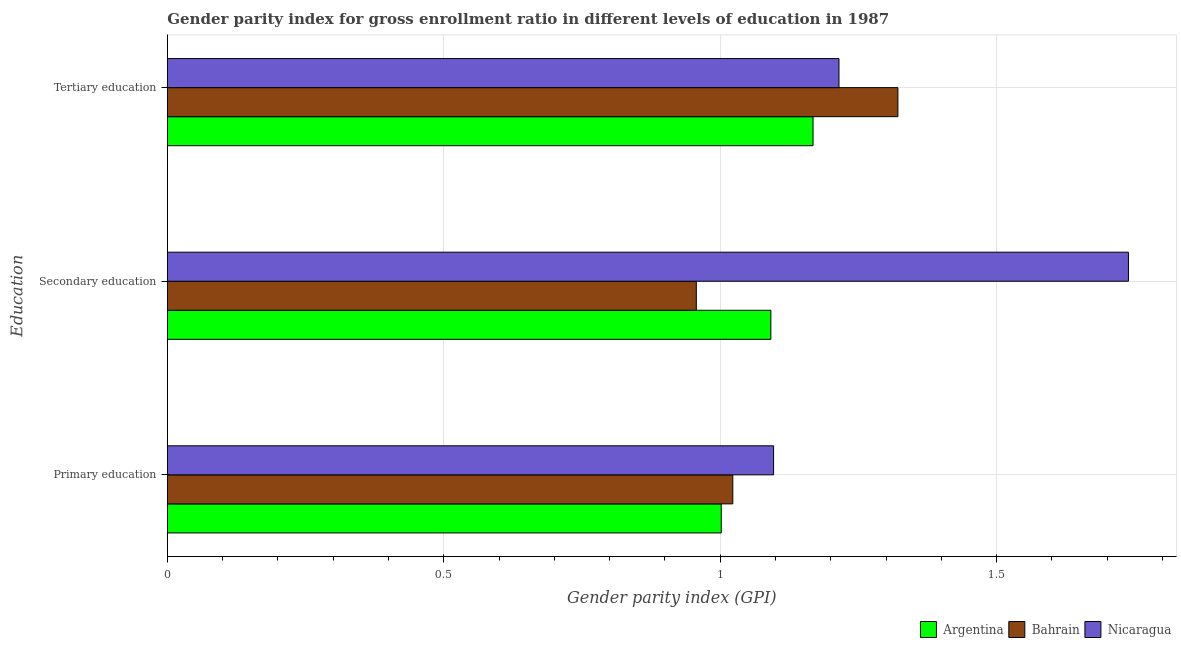How many different coloured bars are there?
Offer a terse response. 3. How many groups of bars are there?
Offer a terse response. 3. Are the number of bars per tick equal to the number of legend labels?
Provide a short and direct response. Yes. Are the number of bars on each tick of the Y-axis equal?
Your answer should be very brief. Yes. How many bars are there on the 1st tick from the top?
Make the answer very short. 3. How many bars are there on the 3rd tick from the bottom?
Provide a short and direct response. 3. What is the label of the 2nd group of bars from the top?
Your response must be concise. Secondary education. What is the gender parity index in primary education in Bahrain?
Offer a very short reply. 1.02. Across all countries, what is the maximum gender parity index in tertiary education?
Your answer should be compact. 1.32. Across all countries, what is the minimum gender parity index in secondary education?
Ensure brevity in your answer.  0.96. In which country was the gender parity index in secondary education maximum?
Your response must be concise. Nicaragua. What is the total gender parity index in secondary education in the graph?
Give a very brief answer. 3.79. What is the difference between the gender parity index in secondary education in Bahrain and that in Nicaragua?
Your answer should be compact. -0.78. What is the difference between the gender parity index in tertiary education in Bahrain and the gender parity index in secondary education in Nicaragua?
Give a very brief answer. -0.42. What is the average gender parity index in primary education per country?
Provide a short and direct response. 1.04. What is the difference between the gender parity index in primary education and gender parity index in secondary education in Argentina?
Your response must be concise. -0.09. In how many countries, is the gender parity index in primary education greater than 0.1 ?
Your answer should be very brief. 3. What is the ratio of the gender parity index in primary education in Bahrain to that in Argentina?
Offer a terse response. 1.02. Is the gender parity index in secondary education in Argentina less than that in Nicaragua?
Ensure brevity in your answer.  Yes. What is the difference between the highest and the second highest gender parity index in tertiary education?
Provide a short and direct response. 0.11. What is the difference between the highest and the lowest gender parity index in primary education?
Offer a terse response. 0.09. In how many countries, is the gender parity index in secondary education greater than the average gender parity index in secondary education taken over all countries?
Your response must be concise. 1. Is the sum of the gender parity index in tertiary education in Nicaragua and Argentina greater than the maximum gender parity index in primary education across all countries?
Keep it short and to the point. Yes. What does the 1st bar from the top in Tertiary education represents?
Your answer should be compact. Nicaragua. What does the 1st bar from the bottom in Secondary education represents?
Offer a very short reply. Argentina. Is it the case that in every country, the sum of the gender parity index in primary education and gender parity index in secondary education is greater than the gender parity index in tertiary education?
Offer a terse response. Yes. How many bars are there?
Your answer should be compact. 9. Are all the bars in the graph horizontal?
Your answer should be very brief. Yes. How many countries are there in the graph?
Provide a short and direct response. 3. Does the graph contain any zero values?
Provide a short and direct response. No. Does the graph contain grids?
Give a very brief answer. Yes. Where does the legend appear in the graph?
Offer a very short reply. Bottom right. How are the legend labels stacked?
Provide a short and direct response. Horizontal. What is the title of the graph?
Make the answer very short. Gender parity index for gross enrollment ratio in different levels of education in 1987. Does "Honduras" appear as one of the legend labels in the graph?
Offer a very short reply. No. What is the label or title of the X-axis?
Make the answer very short. Gender parity index (GPI). What is the label or title of the Y-axis?
Your answer should be compact. Education. What is the Gender parity index (GPI) of Argentina in Primary education?
Your response must be concise. 1. What is the Gender parity index (GPI) of Bahrain in Primary education?
Keep it short and to the point. 1.02. What is the Gender parity index (GPI) of Nicaragua in Primary education?
Offer a terse response. 1.1. What is the Gender parity index (GPI) of Argentina in Secondary education?
Give a very brief answer. 1.09. What is the Gender parity index (GPI) of Bahrain in Secondary education?
Keep it short and to the point. 0.96. What is the Gender parity index (GPI) in Nicaragua in Secondary education?
Ensure brevity in your answer.  1.74. What is the Gender parity index (GPI) in Argentina in Tertiary education?
Offer a terse response. 1.17. What is the Gender parity index (GPI) in Bahrain in Tertiary education?
Your answer should be compact. 1.32. What is the Gender parity index (GPI) of Nicaragua in Tertiary education?
Offer a very short reply. 1.21. Across all Education, what is the maximum Gender parity index (GPI) of Argentina?
Offer a terse response. 1.17. Across all Education, what is the maximum Gender parity index (GPI) of Bahrain?
Your answer should be very brief. 1.32. Across all Education, what is the maximum Gender parity index (GPI) of Nicaragua?
Make the answer very short. 1.74. Across all Education, what is the minimum Gender parity index (GPI) in Argentina?
Give a very brief answer. 1. Across all Education, what is the minimum Gender parity index (GPI) of Bahrain?
Your answer should be very brief. 0.96. Across all Education, what is the minimum Gender parity index (GPI) of Nicaragua?
Keep it short and to the point. 1.1. What is the total Gender parity index (GPI) in Argentina in the graph?
Offer a terse response. 3.26. What is the total Gender parity index (GPI) in Bahrain in the graph?
Make the answer very short. 3.3. What is the total Gender parity index (GPI) of Nicaragua in the graph?
Offer a very short reply. 4.05. What is the difference between the Gender parity index (GPI) of Argentina in Primary education and that in Secondary education?
Ensure brevity in your answer.  -0.09. What is the difference between the Gender parity index (GPI) in Bahrain in Primary education and that in Secondary education?
Your response must be concise. 0.07. What is the difference between the Gender parity index (GPI) of Nicaragua in Primary education and that in Secondary education?
Keep it short and to the point. -0.64. What is the difference between the Gender parity index (GPI) in Argentina in Primary education and that in Tertiary education?
Offer a terse response. -0.17. What is the difference between the Gender parity index (GPI) of Bahrain in Primary education and that in Tertiary education?
Your answer should be compact. -0.3. What is the difference between the Gender parity index (GPI) of Nicaragua in Primary education and that in Tertiary education?
Your answer should be very brief. -0.12. What is the difference between the Gender parity index (GPI) of Argentina in Secondary education and that in Tertiary education?
Your response must be concise. -0.08. What is the difference between the Gender parity index (GPI) in Bahrain in Secondary education and that in Tertiary education?
Keep it short and to the point. -0.36. What is the difference between the Gender parity index (GPI) in Nicaragua in Secondary education and that in Tertiary education?
Give a very brief answer. 0.52. What is the difference between the Gender parity index (GPI) in Argentina in Primary education and the Gender parity index (GPI) in Bahrain in Secondary education?
Provide a succinct answer. 0.05. What is the difference between the Gender parity index (GPI) in Argentina in Primary education and the Gender parity index (GPI) in Nicaragua in Secondary education?
Give a very brief answer. -0.74. What is the difference between the Gender parity index (GPI) of Bahrain in Primary education and the Gender parity index (GPI) of Nicaragua in Secondary education?
Your answer should be compact. -0.72. What is the difference between the Gender parity index (GPI) of Argentina in Primary education and the Gender parity index (GPI) of Bahrain in Tertiary education?
Make the answer very short. -0.32. What is the difference between the Gender parity index (GPI) of Argentina in Primary education and the Gender parity index (GPI) of Nicaragua in Tertiary education?
Your answer should be compact. -0.21. What is the difference between the Gender parity index (GPI) in Bahrain in Primary education and the Gender parity index (GPI) in Nicaragua in Tertiary education?
Ensure brevity in your answer.  -0.19. What is the difference between the Gender parity index (GPI) of Argentina in Secondary education and the Gender parity index (GPI) of Bahrain in Tertiary education?
Keep it short and to the point. -0.23. What is the difference between the Gender parity index (GPI) in Argentina in Secondary education and the Gender parity index (GPI) in Nicaragua in Tertiary education?
Your response must be concise. -0.12. What is the difference between the Gender parity index (GPI) of Bahrain in Secondary education and the Gender parity index (GPI) of Nicaragua in Tertiary education?
Offer a very short reply. -0.26. What is the average Gender parity index (GPI) of Argentina per Education?
Give a very brief answer. 1.09. What is the average Gender parity index (GPI) in Bahrain per Education?
Offer a terse response. 1.1. What is the average Gender parity index (GPI) in Nicaragua per Education?
Give a very brief answer. 1.35. What is the difference between the Gender parity index (GPI) of Argentina and Gender parity index (GPI) of Bahrain in Primary education?
Offer a very short reply. -0.02. What is the difference between the Gender parity index (GPI) of Argentina and Gender parity index (GPI) of Nicaragua in Primary education?
Keep it short and to the point. -0.09. What is the difference between the Gender parity index (GPI) of Bahrain and Gender parity index (GPI) of Nicaragua in Primary education?
Provide a short and direct response. -0.07. What is the difference between the Gender parity index (GPI) in Argentina and Gender parity index (GPI) in Bahrain in Secondary education?
Your answer should be very brief. 0.13. What is the difference between the Gender parity index (GPI) in Argentina and Gender parity index (GPI) in Nicaragua in Secondary education?
Provide a short and direct response. -0.65. What is the difference between the Gender parity index (GPI) of Bahrain and Gender parity index (GPI) of Nicaragua in Secondary education?
Your answer should be compact. -0.78. What is the difference between the Gender parity index (GPI) of Argentina and Gender parity index (GPI) of Bahrain in Tertiary education?
Your answer should be compact. -0.15. What is the difference between the Gender parity index (GPI) in Argentina and Gender parity index (GPI) in Nicaragua in Tertiary education?
Offer a terse response. -0.05. What is the difference between the Gender parity index (GPI) in Bahrain and Gender parity index (GPI) in Nicaragua in Tertiary education?
Give a very brief answer. 0.11. What is the ratio of the Gender parity index (GPI) of Argentina in Primary education to that in Secondary education?
Keep it short and to the point. 0.92. What is the ratio of the Gender parity index (GPI) in Bahrain in Primary education to that in Secondary education?
Your response must be concise. 1.07. What is the ratio of the Gender parity index (GPI) in Nicaragua in Primary education to that in Secondary education?
Your answer should be compact. 0.63. What is the ratio of the Gender parity index (GPI) of Argentina in Primary education to that in Tertiary education?
Keep it short and to the point. 0.86. What is the ratio of the Gender parity index (GPI) in Bahrain in Primary education to that in Tertiary education?
Give a very brief answer. 0.77. What is the ratio of the Gender parity index (GPI) of Nicaragua in Primary education to that in Tertiary education?
Offer a terse response. 0.9. What is the ratio of the Gender parity index (GPI) of Argentina in Secondary education to that in Tertiary education?
Your response must be concise. 0.93. What is the ratio of the Gender parity index (GPI) of Bahrain in Secondary education to that in Tertiary education?
Ensure brevity in your answer.  0.72. What is the ratio of the Gender parity index (GPI) of Nicaragua in Secondary education to that in Tertiary education?
Ensure brevity in your answer.  1.43. What is the difference between the highest and the second highest Gender parity index (GPI) in Argentina?
Your answer should be very brief. 0.08. What is the difference between the highest and the second highest Gender parity index (GPI) of Bahrain?
Offer a very short reply. 0.3. What is the difference between the highest and the second highest Gender parity index (GPI) in Nicaragua?
Your response must be concise. 0.52. What is the difference between the highest and the lowest Gender parity index (GPI) in Argentina?
Provide a succinct answer. 0.17. What is the difference between the highest and the lowest Gender parity index (GPI) of Bahrain?
Your answer should be compact. 0.36. What is the difference between the highest and the lowest Gender parity index (GPI) of Nicaragua?
Your answer should be very brief. 0.64. 